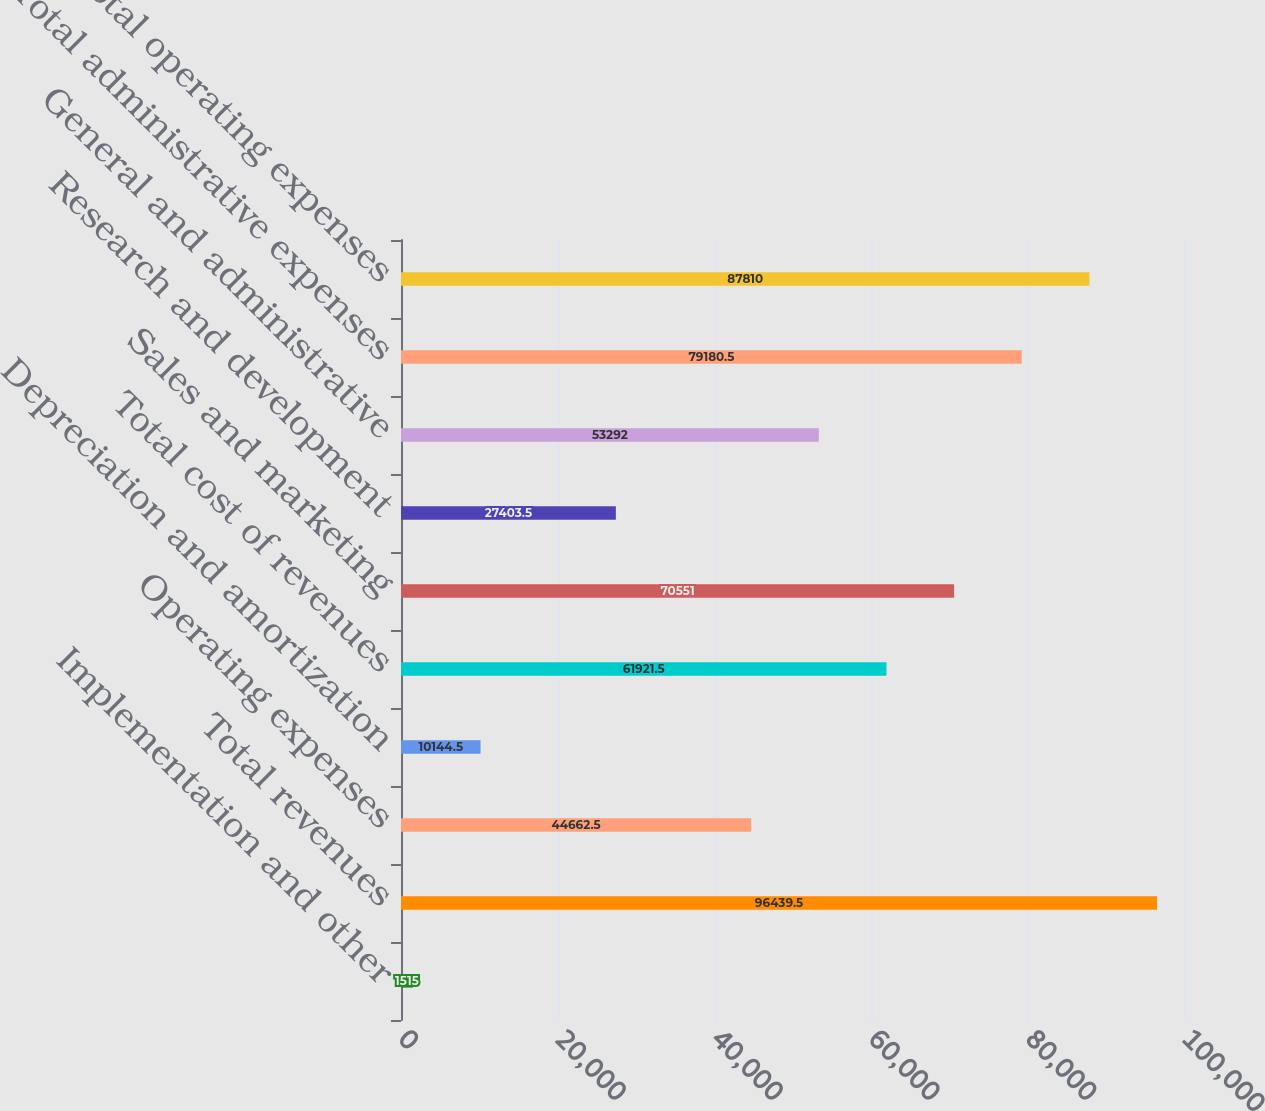<chart> <loc_0><loc_0><loc_500><loc_500><bar_chart><fcel>Implementation and other<fcel>Total revenues<fcel>Operating expenses<fcel>Depreciation and amortization<fcel>Total cost of revenues<fcel>Sales and marketing<fcel>Research and development<fcel>General and administrative<fcel>Total administrative expenses<fcel>Total operating expenses<nl><fcel>1515<fcel>96439.5<fcel>44662.5<fcel>10144.5<fcel>61921.5<fcel>70551<fcel>27403.5<fcel>53292<fcel>79180.5<fcel>87810<nl></chart> 